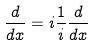Convert formula to latex. <formula><loc_0><loc_0><loc_500><loc_500>\frac { d } { d x } = i \frac { 1 } { i } \frac { d } { d x }</formula> 